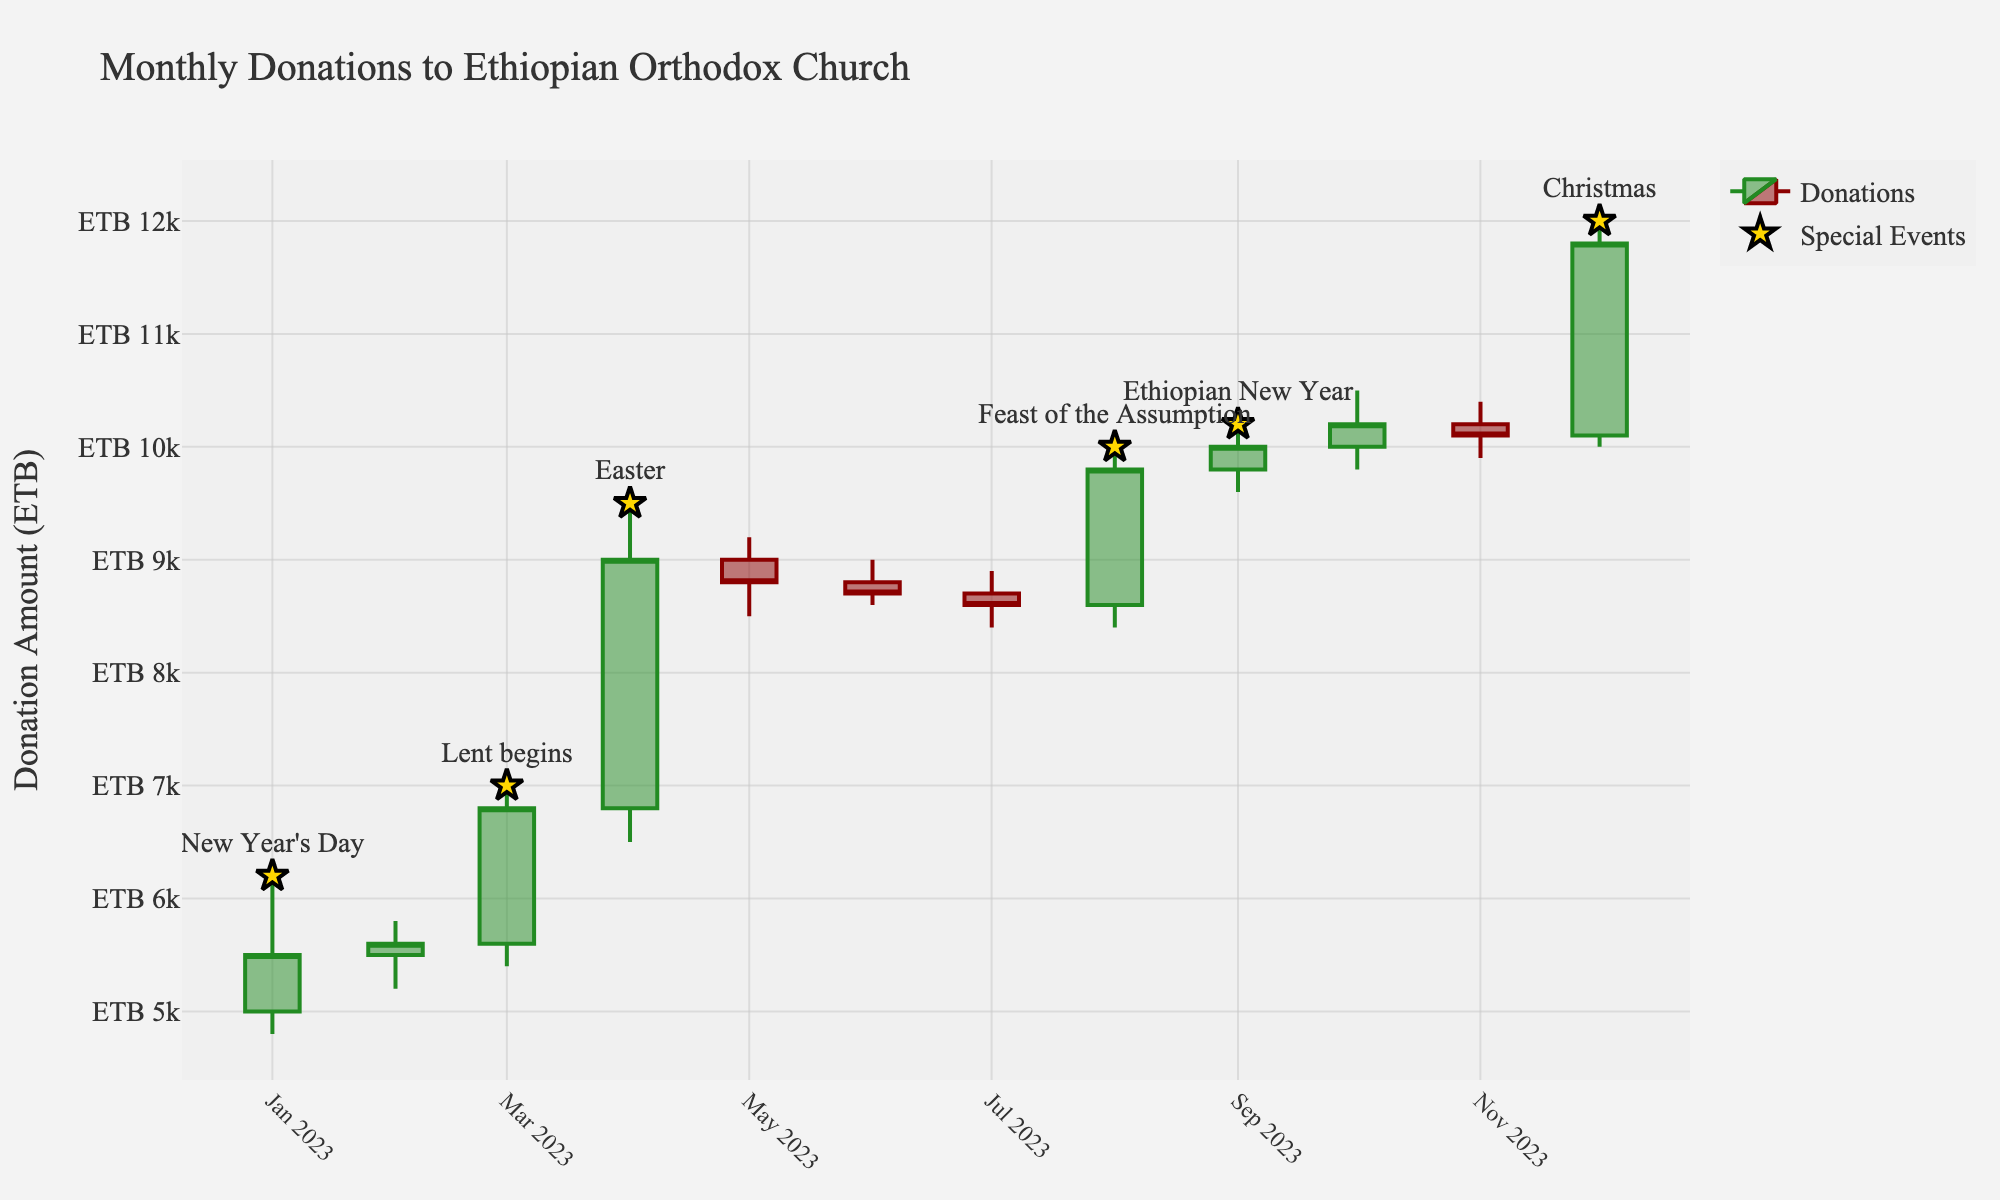**Basic Question**: What is the title of the plot? The title can be found at the top of the plot. It reads, "Monthly Donations to Ethiopian Orthodox Church."
Answer: Monthly Donations to Ethiopian Orthodox Church **Basic Question**: What is the symbol used to mark special events? The special events are marked with star symbols. These are easily identified by their unique gold color and larger size.
Answer: Star **Comparison Question**: During which month did the highest single donation occur? By observing the plot, you can see the highest donation occurs in December, as indicated by the peak at ETB 12,000.
Answer: December **Comparison Question**: Which month had the lowest closing donation amount? By examining the 'Close' values, we see that January had the lowest closing donation amount at ETB 5,500.
Answer: January **Compositional Question**: What is the average closing donation amount over the entire year? To find the average, add all the closing amounts and divide by the number of months. (5500 + 5600 + 6800 + 9000 + 8800 + 8700 + 8600 + 9800 + 10000 + 10200 + 10100 + 11800) / 12 = 8,425.
Answer: 8,425 ETB **Comparison Question**: How did the closing donation amount change from August to September? The closing donation amount in August was ETB 9,800, and in September it was ETB 10,000. The change is 10,000 - 9,800 = 200 ETB.
Answer: 200 ETB increase **Chart-Type Specific Question**: What does the color of the candlestick indicate about donations in a particular month? Green candlesticks indicate an increase in donation amount from the open to close, while red candlesticks indicate a decrease. For example, January has a green candlestick showing an increase, while November has a red candlestick showing a decrease from October.
Answer: Green (increase), Red (decrease) **Comparison Question**: During which special event did the highest closing donation occur? By identifying the special events marked with stars, we see that the highest closing donation during a special event was during Christmas (December) with ETB 11,800.
Answer: Christmas **Compositional Question**: What is the range of donation amounts in March? The high and low donation amounts for March are 7,000 and 5,400, respectively. The range is calculated as 7,000 - 5,400 = 1,600 ETB.
Answer: 1,600 ETB **Chart-Type Specific Question**: What information is conveyed by the 'Open' and 'Close' values for each month? 'Open' represents the donation amount at the beginning of the month, and 'Close' represents the amount at the end. For January, 'Open' is ETB 5,000 and 'Close' is ETB 5,500, indicating an increase over the month.
Answer: 'Open' (beginning), 'Close' (end) 